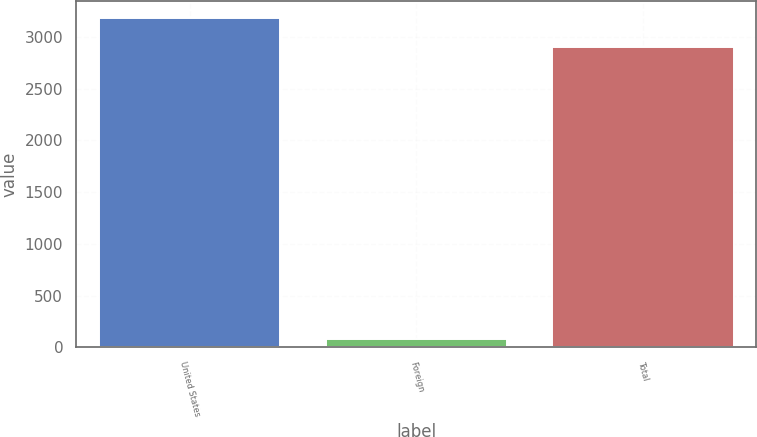<chart> <loc_0><loc_0><loc_500><loc_500><bar_chart><fcel>United States<fcel>Foreign<fcel>Total<nl><fcel>3187.8<fcel>80.7<fcel>2898<nl></chart> 